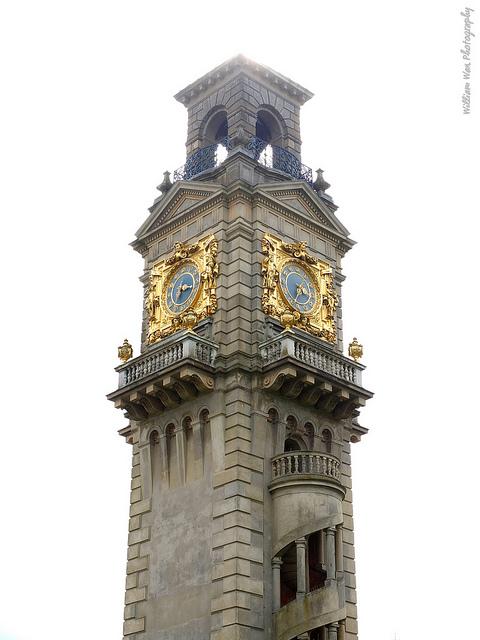What city is this clock tower in?
Concise answer only. London. What are the gold objects on the clock?
Quick response, please. Designs. Do both sides of the clock match times?
Write a very short answer. Yes. Is that a small clock?
Be succinct. No. 